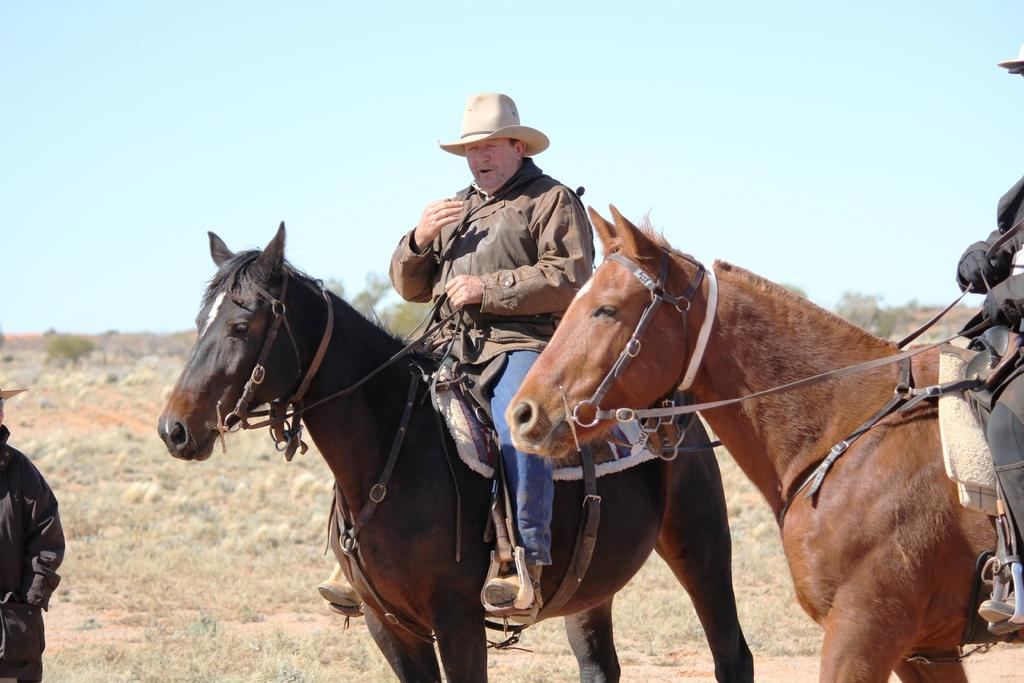What is the person in the image wearing on their head? The person in the image is wearing a hat. What is the person wearing a hat doing in the image? The person wearing a hat is sitting on a horse. Are there any other people on horses in the image? Yes, there is another person sitting on a horse beside the person wearing a hat. Can you describe the person standing in the image? There is a person standing in the left corner of the image. What type of disease is the horse in the image suffering from? There is no indication in the image that the horse is suffering from any disease. 